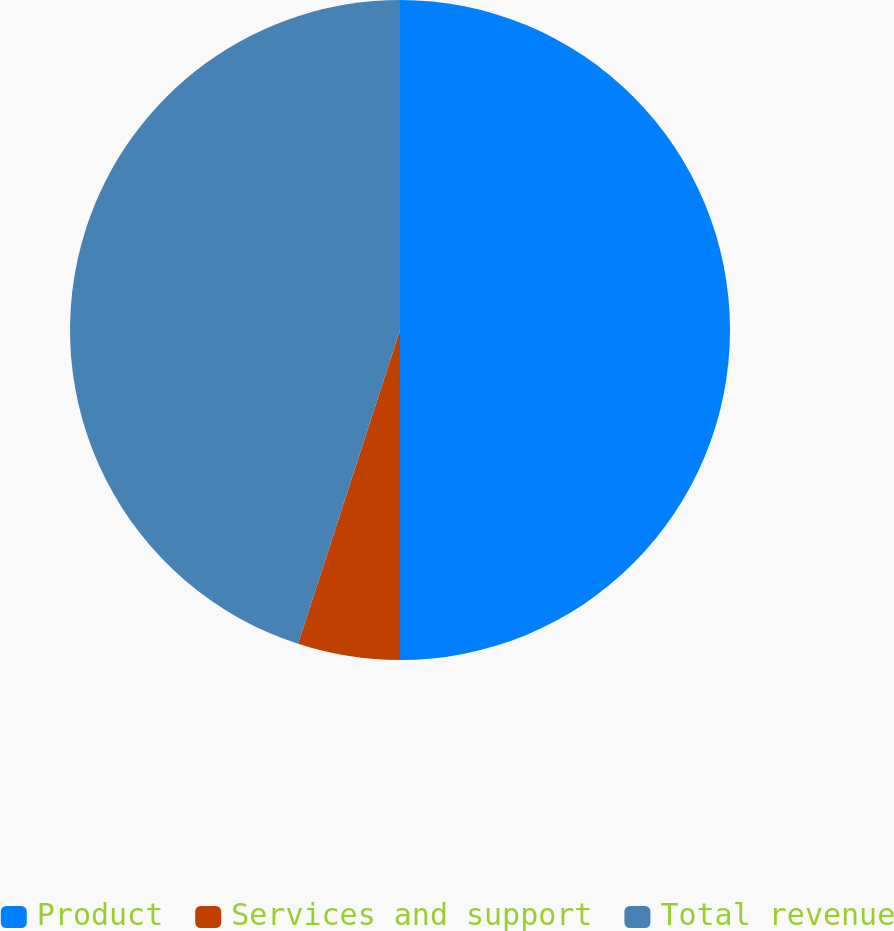Convert chart. <chart><loc_0><loc_0><loc_500><loc_500><pie_chart><fcel>Product<fcel>Services and support<fcel>Total revenue<nl><fcel>50.0%<fcel>5.0%<fcel>45.0%<nl></chart> 